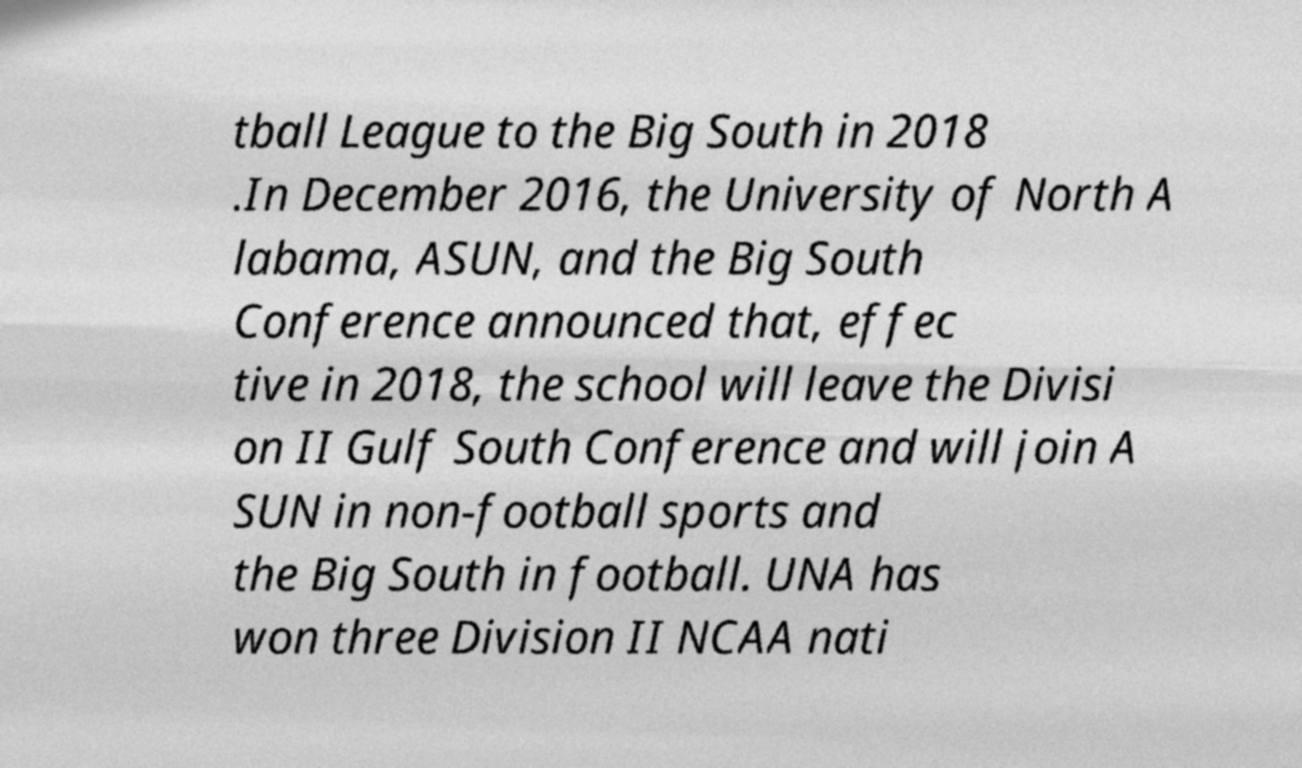For documentation purposes, I need the text within this image transcribed. Could you provide that? tball League to the Big South in 2018 .In December 2016, the University of North A labama, ASUN, and the Big South Conference announced that, effec tive in 2018, the school will leave the Divisi on II Gulf South Conference and will join A SUN in non-football sports and the Big South in football. UNA has won three Division II NCAA nati 